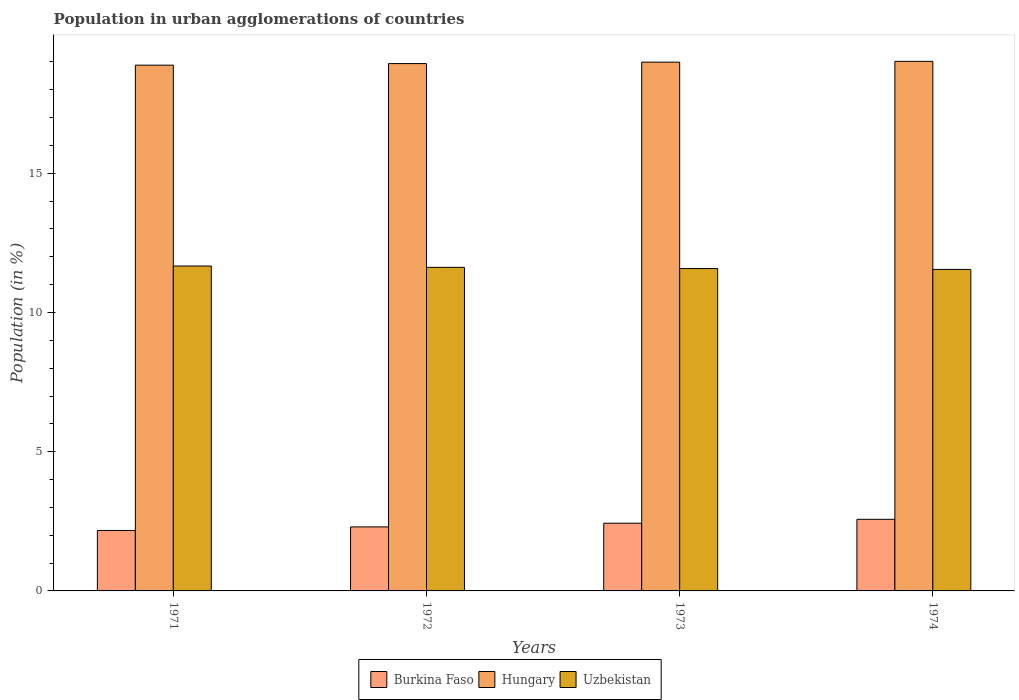Are the number of bars per tick equal to the number of legend labels?
Ensure brevity in your answer.  Yes. How many bars are there on the 2nd tick from the right?
Your answer should be very brief. 3. In how many cases, is the number of bars for a given year not equal to the number of legend labels?
Your response must be concise. 0. What is the percentage of population in urban agglomerations in Uzbekistan in 1973?
Make the answer very short. 11.58. Across all years, what is the maximum percentage of population in urban agglomerations in Hungary?
Keep it short and to the point. 19.02. Across all years, what is the minimum percentage of population in urban agglomerations in Uzbekistan?
Your answer should be compact. 11.55. In which year was the percentage of population in urban agglomerations in Burkina Faso maximum?
Ensure brevity in your answer.  1974. In which year was the percentage of population in urban agglomerations in Hungary minimum?
Offer a terse response. 1971. What is the total percentage of population in urban agglomerations in Uzbekistan in the graph?
Your response must be concise. 46.41. What is the difference between the percentage of population in urban agglomerations in Burkina Faso in 1971 and that in 1974?
Ensure brevity in your answer.  -0.4. What is the difference between the percentage of population in urban agglomerations in Uzbekistan in 1973 and the percentage of population in urban agglomerations in Burkina Faso in 1972?
Your answer should be very brief. 9.28. What is the average percentage of population in urban agglomerations in Uzbekistan per year?
Provide a succinct answer. 11.6. In the year 1973, what is the difference between the percentage of population in urban agglomerations in Hungary and percentage of population in urban agglomerations in Burkina Faso?
Provide a succinct answer. 16.56. In how many years, is the percentage of population in urban agglomerations in Burkina Faso greater than 3 %?
Provide a short and direct response. 0. What is the ratio of the percentage of population in urban agglomerations in Uzbekistan in 1971 to that in 1972?
Keep it short and to the point. 1. What is the difference between the highest and the second highest percentage of population in urban agglomerations in Burkina Faso?
Provide a short and direct response. 0.14. What is the difference between the highest and the lowest percentage of population in urban agglomerations in Burkina Faso?
Your answer should be very brief. 0.4. What does the 1st bar from the left in 1972 represents?
Your answer should be compact. Burkina Faso. What does the 3rd bar from the right in 1972 represents?
Ensure brevity in your answer.  Burkina Faso. Is it the case that in every year, the sum of the percentage of population in urban agglomerations in Uzbekistan and percentage of population in urban agglomerations in Hungary is greater than the percentage of population in urban agglomerations in Burkina Faso?
Keep it short and to the point. Yes. How many bars are there?
Your answer should be very brief. 12. What is the difference between two consecutive major ticks on the Y-axis?
Make the answer very short. 5. Are the values on the major ticks of Y-axis written in scientific E-notation?
Your answer should be compact. No. Does the graph contain any zero values?
Offer a terse response. No. How many legend labels are there?
Ensure brevity in your answer.  3. How are the legend labels stacked?
Make the answer very short. Horizontal. What is the title of the graph?
Your response must be concise. Population in urban agglomerations of countries. Does "Israel" appear as one of the legend labels in the graph?
Make the answer very short. No. What is the label or title of the X-axis?
Your answer should be very brief. Years. What is the label or title of the Y-axis?
Offer a very short reply. Population (in %). What is the Population (in %) in Burkina Faso in 1971?
Give a very brief answer. 2.17. What is the Population (in %) in Hungary in 1971?
Give a very brief answer. 18.88. What is the Population (in %) in Uzbekistan in 1971?
Offer a terse response. 11.67. What is the Population (in %) of Burkina Faso in 1972?
Your response must be concise. 2.3. What is the Population (in %) in Hungary in 1972?
Offer a very short reply. 18.94. What is the Population (in %) of Uzbekistan in 1972?
Offer a very short reply. 11.62. What is the Population (in %) of Burkina Faso in 1973?
Provide a succinct answer. 2.43. What is the Population (in %) of Hungary in 1973?
Give a very brief answer. 18.99. What is the Population (in %) in Uzbekistan in 1973?
Ensure brevity in your answer.  11.58. What is the Population (in %) in Burkina Faso in 1974?
Keep it short and to the point. 2.57. What is the Population (in %) of Hungary in 1974?
Your answer should be compact. 19.02. What is the Population (in %) in Uzbekistan in 1974?
Make the answer very short. 11.55. Across all years, what is the maximum Population (in %) in Burkina Faso?
Offer a very short reply. 2.57. Across all years, what is the maximum Population (in %) of Hungary?
Offer a very short reply. 19.02. Across all years, what is the maximum Population (in %) of Uzbekistan?
Offer a terse response. 11.67. Across all years, what is the minimum Population (in %) in Burkina Faso?
Offer a terse response. 2.17. Across all years, what is the minimum Population (in %) of Hungary?
Your answer should be compact. 18.88. Across all years, what is the minimum Population (in %) in Uzbekistan?
Provide a succinct answer. 11.55. What is the total Population (in %) of Burkina Faso in the graph?
Ensure brevity in your answer.  9.47. What is the total Population (in %) of Hungary in the graph?
Keep it short and to the point. 75.83. What is the total Population (in %) in Uzbekistan in the graph?
Ensure brevity in your answer.  46.41. What is the difference between the Population (in %) of Burkina Faso in 1971 and that in 1972?
Provide a short and direct response. -0.13. What is the difference between the Population (in %) of Hungary in 1971 and that in 1972?
Offer a very short reply. -0.06. What is the difference between the Population (in %) of Uzbekistan in 1971 and that in 1972?
Keep it short and to the point. 0.05. What is the difference between the Population (in %) in Burkina Faso in 1971 and that in 1973?
Give a very brief answer. -0.26. What is the difference between the Population (in %) in Hungary in 1971 and that in 1973?
Give a very brief answer. -0.11. What is the difference between the Population (in %) of Uzbekistan in 1971 and that in 1973?
Your answer should be very brief. 0.09. What is the difference between the Population (in %) of Burkina Faso in 1971 and that in 1974?
Offer a terse response. -0.4. What is the difference between the Population (in %) in Hungary in 1971 and that in 1974?
Give a very brief answer. -0.14. What is the difference between the Population (in %) of Uzbekistan in 1971 and that in 1974?
Give a very brief answer. 0.12. What is the difference between the Population (in %) in Burkina Faso in 1972 and that in 1973?
Keep it short and to the point. -0.13. What is the difference between the Population (in %) of Hungary in 1972 and that in 1973?
Make the answer very short. -0.05. What is the difference between the Population (in %) in Uzbekistan in 1972 and that in 1973?
Provide a succinct answer. 0.04. What is the difference between the Population (in %) in Burkina Faso in 1972 and that in 1974?
Make the answer very short. -0.27. What is the difference between the Population (in %) of Hungary in 1972 and that in 1974?
Make the answer very short. -0.08. What is the difference between the Population (in %) of Uzbekistan in 1972 and that in 1974?
Offer a very short reply. 0.07. What is the difference between the Population (in %) in Burkina Faso in 1973 and that in 1974?
Your answer should be compact. -0.14. What is the difference between the Population (in %) in Hungary in 1973 and that in 1974?
Make the answer very short. -0.03. What is the difference between the Population (in %) in Uzbekistan in 1973 and that in 1974?
Offer a very short reply. 0.03. What is the difference between the Population (in %) in Burkina Faso in 1971 and the Population (in %) in Hungary in 1972?
Offer a terse response. -16.77. What is the difference between the Population (in %) of Burkina Faso in 1971 and the Population (in %) of Uzbekistan in 1972?
Your answer should be very brief. -9.45. What is the difference between the Population (in %) in Hungary in 1971 and the Population (in %) in Uzbekistan in 1972?
Offer a very short reply. 7.26. What is the difference between the Population (in %) in Burkina Faso in 1971 and the Population (in %) in Hungary in 1973?
Your answer should be very brief. -16.82. What is the difference between the Population (in %) in Burkina Faso in 1971 and the Population (in %) in Uzbekistan in 1973?
Keep it short and to the point. -9.41. What is the difference between the Population (in %) in Hungary in 1971 and the Population (in %) in Uzbekistan in 1973?
Your answer should be compact. 7.3. What is the difference between the Population (in %) in Burkina Faso in 1971 and the Population (in %) in Hungary in 1974?
Ensure brevity in your answer.  -16.85. What is the difference between the Population (in %) in Burkina Faso in 1971 and the Population (in %) in Uzbekistan in 1974?
Keep it short and to the point. -9.37. What is the difference between the Population (in %) in Hungary in 1971 and the Population (in %) in Uzbekistan in 1974?
Offer a terse response. 7.34. What is the difference between the Population (in %) in Burkina Faso in 1972 and the Population (in %) in Hungary in 1973?
Offer a terse response. -16.69. What is the difference between the Population (in %) in Burkina Faso in 1972 and the Population (in %) in Uzbekistan in 1973?
Make the answer very short. -9.28. What is the difference between the Population (in %) in Hungary in 1972 and the Population (in %) in Uzbekistan in 1973?
Offer a very short reply. 7.36. What is the difference between the Population (in %) of Burkina Faso in 1972 and the Population (in %) of Hungary in 1974?
Your answer should be very brief. -16.72. What is the difference between the Population (in %) of Burkina Faso in 1972 and the Population (in %) of Uzbekistan in 1974?
Ensure brevity in your answer.  -9.25. What is the difference between the Population (in %) in Hungary in 1972 and the Population (in %) in Uzbekistan in 1974?
Give a very brief answer. 7.39. What is the difference between the Population (in %) of Burkina Faso in 1973 and the Population (in %) of Hungary in 1974?
Make the answer very short. -16.59. What is the difference between the Population (in %) in Burkina Faso in 1973 and the Population (in %) in Uzbekistan in 1974?
Keep it short and to the point. -9.11. What is the difference between the Population (in %) in Hungary in 1973 and the Population (in %) in Uzbekistan in 1974?
Offer a terse response. 7.44. What is the average Population (in %) of Burkina Faso per year?
Offer a very short reply. 2.37. What is the average Population (in %) of Hungary per year?
Provide a short and direct response. 18.96. What is the average Population (in %) in Uzbekistan per year?
Keep it short and to the point. 11.6. In the year 1971, what is the difference between the Population (in %) in Burkina Faso and Population (in %) in Hungary?
Your response must be concise. -16.71. In the year 1971, what is the difference between the Population (in %) in Burkina Faso and Population (in %) in Uzbekistan?
Keep it short and to the point. -9.5. In the year 1971, what is the difference between the Population (in %) of Hungary and Population (in %) of Uzbekistan?
Your response must be concise. 7.21. In the year 1972, what is the difference between the Population (in %) in Burkina Faso and Population (in %) in Hungary?
Provide a short and direct response. -16.64. In the year 1972, what is the difference between the Population (in %) of Burkina Faso and Population (in %) of Uzbekistan?
Your response must be concise. -9.32. In the year 1972, what is the difference between the Population (in %) of Hungary and Population (in %) of Uzbekistan?
Provide a succinct answer. 7.32. In the year 1973, what is the difference between the Population (in %) in Burkina Faso and Population (in %) in Hungary?
Keep it short and to the point. -16.56. In the year 1973, what is the difference between the Population (in %) in Burkina Faso and Population (in %) in Uzbekistan?
Provide a succinct answer. -9.15. In the year 1973, what is the difference between the Population (in %) of Hungary and Population (in %) of Uzbekistan?
Make the answer very short. 7.41. In the year 1974, what is the difference between the Population (in %) of Burkina Faso and Population (in %) of Hungary?
Provide a succinct answer. -16.45. In the year 1974, what is the difference between the Population (in %) of Burkina Faso and Population (in %) of Uzbekistan?
Give a very brief answer. -8.97. In the year 1974, what is the difference between the Population (in %) of Hungary and Population (in %) of Uzbekistan?
Your answer should be very brief. 7.47. What is the ratio of the Population (in %) in Burkina Faso in 1971 to that in 1972?
Your answer should be compact. 0.94. What is the ratio of the Population (in %) of Hungary in 1971 to that in 1972?
Make the answer very short. 1. What is the ratio of the Population (in %) of Uzbekistan in 1971 to that in 1972?
Your answer should be very brief. 1. What is the ratio of the Population (in %) of Burkina Faso in 1971 to that in 1973?
Your answer should be very brief. 0.89. What is the ratio of the Population (in %) in Hungary in 1971 to that in 1973?
Offer a terse response. 0.99. What is the ratio of the Population (in %) of Uzbekistan in 1971 to that in 1973?
Keep it short and to the point. 1.01. What is the ratio of the Population (in %) of Burkina Faso in 1971 to that in 1974?
Keep it short and to the point. 0.84. What is the ratio of the Population (in %) in Uzbekistan in 1971 to that in 1974?
Offer a terse response. 1.01. What is the ratio of the Population (in %) of Burkina Faso in 1972 to that in 1973?
Your response must be concise. 0.95. What is the ratio of the Population (in %) in Hungary in 1972 to that in 1973?
Offer a very short reply. 1. What is the ratio of the Population (in %) in Uzbekistan in 1972 to that in 1973?
Provide a short and direct response. 1. What is the ratio of the Population (in %) in Burkina Faso in 1972 to that in 1974?
Your answer should be very brief. 0.89. What is the ratio of the Population (in %) of Uzbekistan in 1972 to that in 1974?
Ensure brevity in your answer.  1.01. What is the ratio of the Population (in %) of Burkina Faso in 1973 to that in 1974?
Offer a very short reply. 0.95. What is the ratio of the Population (in %) in Uzbekistan in 1973 to that in 1974?
Offer a terse response. 1. What is the difference between the highest and the second highest Population (in %) of Burkina Faso?
Give a very brief answer. 0.14. What is the difference between the highest and the second highest Population (in %) of Hungary?
Keep it short and to the point. 0.03. What is the difference between the highest and the second highest Population (in %) in Uzbekistan?
Provide a succinct answer. 0.05. What is the difference between the highest and the lowest Population (in %) of Burkina Faso?
Make the answer very short. 0.4. What is the difference between the highest and the lowest Population (in %) in Hungary?
Keep it short and to the point. 0.14. What is the difference between the highest and the lowest Population (in %) in Uzbekistan?
Keep it short and to the point. 0.12. 